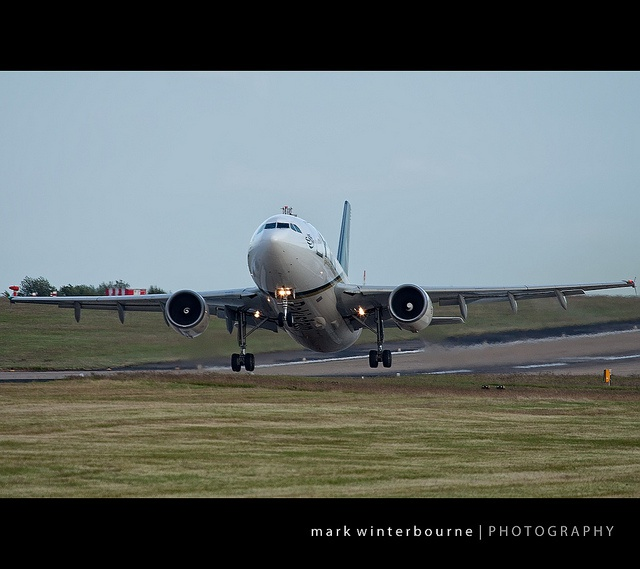Describe the objects in this image and their specific colors. I can see a airplane in black, gray, and darkgray tones in this image. 